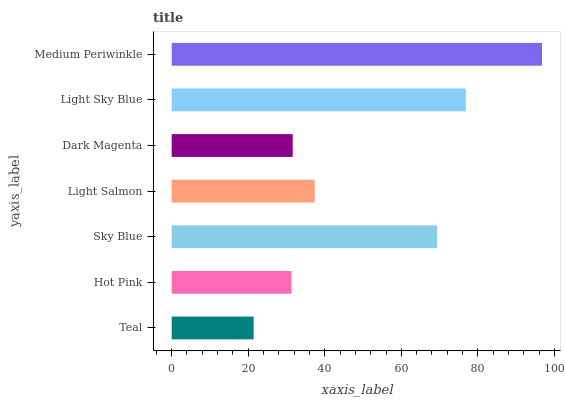Is Teal the minimum?
Answer yes or no. Yes. Is Medium Periwinkle the maximum?
Answer yes or no. Yes. Is Hot Pink the minimum?
Answer yes or no. No. Is Hot Pink the maximum?
Answer yes or no. No. Is Hot Pink greater than Teal?
Answer yes or no. Yes. Is Teal less than Hot Pink?
Answer yes or no. Yes. Is Teal greater than Hot Pink?
Answer yes or no. No. Is Hot Pink less than Teal?
Answer yes or no. No. Is Light Salmon the high median?
Answer yes or no. Yes. Is Light Salmon the low median?
Answer yes or no. Yes. Is Medium Periwinkle the high median?
Answer yes or no. No. Is Medium Periwinkle the low median?
Answer yes or no. No. 